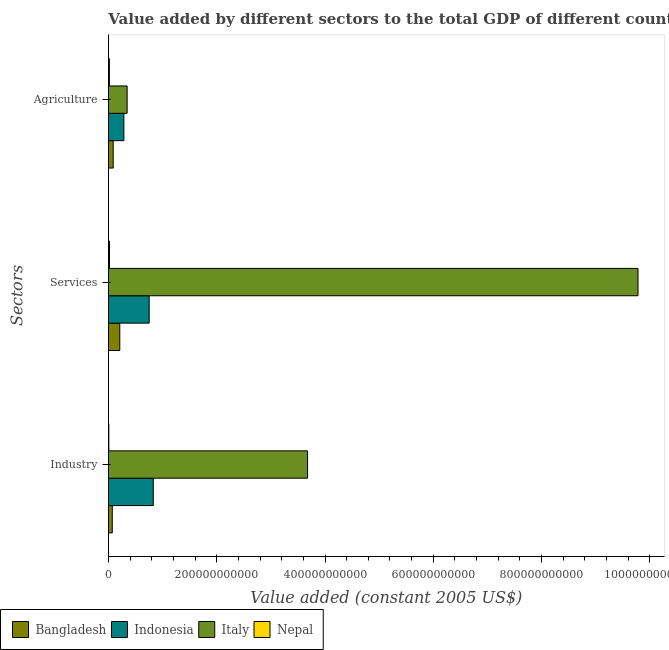How many different coloured bars are there?
Keep it short and to the point. 4. How many groups of bars are there?
Ensure brevity in your answer.  3. Are the number of bars per tick equal to the number of legend labels?
Ensure brevity in your answer.  Yes. How many bars are there on the 1st tick from the top?
Provide a succinct answer. 4. What is the label of the 1st group of bars from the top?
Provide a short and direct response. Agriculture. What is the value added by agricultural sector in Nepal?
Provide a succinct answer. 1.80e+09. Across all countries, what is the maximum value added by agricultural sector?
Give a very brief answer. 3.46e+1. Across all countries, what is the minimum value added by industrial sector?
Offer a terse response. 7.76e+08. In which country was the value added by services minimum?
Offer a terse response. Nepal. What is the total value added by industrial sector in the graph?
Your answer should be compact. 4.59e+11. What is the difference between the value added by industrial sector in Italy and that in Nepal?
Provide a succinct answer. 3.67e+11. What is the difference between the value added by industrial sector in Indonesia and the value added by agricultural sector in Bangladesh?
Offer a terse response. 7.40e+1. What is the average value added by industrial sector per country?
Your answer should be compact. 1.15e+11. What is the difference between the value added by industrial sector and value added by agricultural sector in Nepal?
Offer a terse response. -1.02e+09. In how many countries, is the value added by services greater than 480000000000 US$?
Keep it short and to the point. 1. What is the ratio of the value added by agricultural sector in Bangladesh to that in Italy?
Offer a very short reply. 0.25. Is the difference between the value added by services in Indonesia and Italy greater than the difference between the value added by agricultural sector in Indonesia and Italy?
Give a very brief answer. No. What is the difference between the highest and the second highest value added by services?
Give a very brief answer. 9.03e+11. What is the difference between the highest and the lowest value added by industrial sector?
Your answer should be compact. 3.67e+11. Is the sum of the value added by industrial sector in Indonesia and Bangladesh greater than the maximum value added by services across all countries?
Make the answer very short. No. Is it the case that in every country, the sum of the value added by industrial sector and value added by services is greater than the value added by agricultural sector?
Make the answer very short. Yes. How many countries are there in the graph?
Provide a short and direct response. 4. What is the difference between two consecutive major ticks on the X-axis?
Your answer should be very brief. 2.00e+11. Does the graph contain any zero values?
Provide a succinct answer. No. Where does the legend appear in the graph?
Your response must be concise. Bottom left. How many legend labels are there?
Your answer should be compact. 4. What is the title of the graph?
Offer a terse response. Value added by different sectors to the total GDP of different countries. What is the label or title of the X-axis?
Ensure brevity in your answer.  Value added (constant 2005 US$). What is the label or title of the Y-axis?
Your answer should be compact. Sectors. What is the Value added (constant 2005 US$) of Bangladesh in Industry?
Your response must be concise. 7.11e+09. What is the Value added (constant 2005 US$) in Indonesia in Industry?
Your answer should be compact. 8.29e+1. What is the Value added (constant 2005 US$) of Italy in Industry?
Your answer should be very brief. 3.68e+11. What is the Value added (constant 2005 US$) of Nepal in Industry?
Your answer should be very brief. 7.76e+08. What is the Value added (constant 2005 US$) in Bangladesh in Services?
Offer a very short reply. 2.10e+1. What is the Value added (constant 2005 US$) in Indonesia in Services?
Offer a very short reply. 7.53e+1. What is the Value added (constant 2005 US$) of Italy in Services?
Keep it short and to the point. 9.78e+11. What is the Value added (constant 2005 US$) of Nepal in Services?
Give a very brief answer. 2.01e+09. What is the Value added (constant 2005 US$) of Bangladesh in Agriculture?
Your response must be concise. 8.81e+09. What is the Value added (constant 2005 US$) of Indonesia in Agriculture?
Provide a succinct answer. 2.85e+1. What is the Value added (constant 2005 US$) in Italy in Agriculture?
Keep it short and to the point. 3.46e+1. What is the Value added (constant 2005 US$) of Nepal in Agriculture?
Offer a terse response. 1.80e+09. Across all Sectors, what is the maximum Value added (constant 2005 US$) in Bangladesh?
Provide a succinct answer. 2.10e+1. Across all Sectors, what is the maximum Value added (constant 2005 US$) of Indonesia?
Your answer should be very brief. 8.29e+1. Across all Sectors, what is the maximum Value added (constant 2005 US$) in Italy?
Your answer should be compact. 9.78e+11. Across all Sectors, what is the maximum Value added (constant 2005 US$) of Nepal?
Provide a short and direct response. 2.01e+09. Across all Sectors, what is the minimum Value added (constant 2005 US$) of Bangladesh?
Keep it short and to the point. 7.11e+09. Across all Sectors, what is the minimum Value added (constant 2005 US$) of Indonesia?
Your response must be concise. 2.85e+1. Across all Sectors, what is the minimum Value added (constant 2005 US$) in Italy?
Provide a succinct answer. 3.46e+1. Across all Sectors, what is the minimum Value added (constant 2005 US$) of Nepal?
Offer a terse response. 7.76e+08. What is the total Value added (constant 2005 US$) of Bangladesh in the graph?
Provide a succinct answer. 3.69e+1. What is the total Value added (constant 2005 US$) of Indonesia in the graph?
Your answer should be compact. 1.87e+11. What is the total Value added (constant 2005 US$) of Italy in the graph?
Offer a terse response. 1.38e+12. What is the total Value added (constant 2005 US$) in Nepal in the graph?
Offer a very short reply. 4.59e+09. What is the difference between the Value added (constant 2005 US$) in Bangladesh in Industry and that in Services?
Ensure brevity in your answer.  -1.39e+1. What is the difference between the Value added (constant 2005 US$) in Indonesia in Industry and that in Services?
Offer a very short reply. 7.56e+09. What is the difference between the Value added (constant 2005 US$) of Italy in Industry and that in Services?
Your answer should be compact. -6.10e+11. What is the difference between the Value added (constant 2005 US$) of Nepal in Industry and that in Services?
Provide a short and direct response. -1.24e+09. What is the difference between the Value added (constant 2005 US$) of Bangladesh in Industry and that in Agriculture?
Provide a short and direct response. -1.70e+09. What is the difference between the Value added (constant 2005 US$) of Indonesia in Industry and that in Agriculture?
Keep it short and to the point. 5.43e+1. What is the difference between the Value added (constant 2005 US$) of Italy in Industry and that in Agriculture?
Make the answer very short. 3.33e+11. What is the difference between the Value added (constant 2005 US$) in Nepal in Industry and that in Agriculture?
Provide a succinct answer. -1.02e+09. What is the difference between the Value added (constant 2005 US$) in Bangladesh in Services and that in Agriculture?
Give a very brief answer. 1.22e+1. What is the difference between the Value added (constant 2005 US$) in Indonesia in Services and that in Agriculture?
Make the answer very short. 4.67e+1. What is the difference between the Value added (constant 2005 US$) in Italy in Services and that in Agriculture?
Give a very brief answer. 9.44e+11. What is the difference between the Value added (constant 2005 US$) in Nepal in Services and that in Agriculture?
Your answer should be compact. 2.19e+08. What is the difference between the Value added (constant 2005 US$) in Bangladesh in Industry and the Value added (constant 2005 US$) in Indonesia in Services?
Keep it short and to the point. -6.82e+1. What is the difference between the Value added (constant 2005 US$) in Bangladesh in Industry and the Value added (constant 2005 US$) in Italy in Services?
Make the answer very short. -9.71e+11. What is the difference between the Value added (constant 2005 US$) of Bangladesh in Industry and the Value added (constant 2005 US$) of Nepal in Services?
Keep it short and to the point. 5.09e+09. What is the difference between the Value added (constant 2005 US$) of Indonesia in Industry and the Value added (constant 2005 US$) of Italy in Services?
Make the answer very short. -8.95e+11. What is the difference between the Value added (constant 2005 US$) of Indonesia in Industry and the Value added (constant 2005 US$) of Nepal in Services?
Give a very brief answer. 8.08e+1. What is the difference between the Value added (constant 2005 US$) in Italy in Industry and the Value added (constant 2005 US$) in Nepal in Services?
Your answer should be very brief. 3.66e+11. What is the difference between the Value added (constant 2005 US$) of Bangladesh in Industry and the Value added (constant 2005 US$) of Indonesia in Agriculture?
Provide a short and direct response. -2.14e+1. What is the difference between the Value added (constant 2005 US$) in Bangladesh in Industry and the Value added (constant 2005 US$) in Italy in Agriculture?
Offer a terse response. -2.75e+1. What is the difference between the Value added (constant 2005 US$) of Bangladesh in Industry and the Value added (constant 2005 US$) of Nepal in Agriculture?
Your answer should be very brief. 5.31e+09. What is the difference between the Value added (constant 2005 US$) of Indonesia in Industry and the Value added (constant 2005 US$) of Italy in Agriculture?
Provide a short and direct response. 4.83e+1. What is the difference between the Value added (constant 2005 US$) of Indonesia in Industry and the Value added (constant 2005 US$) of Nepal in Agriculture?
Offer a very short reply. 8.11e+1. What is the difference between the Value added (constant 2005 US$) in Italy in Industry and the Value added (constant 2005 US$) in Nepal in Agriculture?
Ensure brevity in your answer.  3.66e+11. What is the difference between the Value added (constant 2005 US$) in Bangladesh in Services and the Value added (constant 2005 US$) in Indonesia in Agriculture?
Your answer should be compact. -7.58e+09. What is the difference between the Value added (constant 2005 US$) of Bangladesh in Services and the Value added (constant 2005 US$) of Italy in Agriculture?
Offer a very short reply. -1.36e+1. What is the difference between the Value added (constant 2005 US$) of Bangladesh in Services and the Value added (constant 2005 US$) of Nepal in Agriculture?
Provide a short and direct response. 1.92e+1. What is the difference between the Value added (constant 2005 US$) in Indonesia in Services and the Value added (constant 2005 US$) in Italy in Agriculture?
Your answer should be compact. 4.07e+1. What is the difference between the Value added (constant 2005 US$) in Indonesia in Services and the Value added (constant 2005 US$) in Nepal in Agriculture?
Provide a short and direct response. 7.35e+1. What is the difference between the Value added (constant 2005 US$) in Italy in Services and the Value added (constant 2005 US$) in Nepal in Agriculture?
Ensure brevity in your answer.  9.76e+11. What is the average Value added (constant 2005 US$) of Bangladesh per Sectors?
Give a very brief answer. 1.23e+1. What is the average Value added (constant 2005 US$) of Indonesia per Sectors?
Provide a succinct answer. 6.22e+1. What is the average Value added (constant 2005 US$) in Italy per Sectors?
Make the answer very short. 4.60e+11. What is the average Value added (constant 2005 US$) in Nepal per Sectors?
Your answer should be compact. 1.53e+09. What is the difference between the Value added (constant 2005 US$) of Bangladesh and Value added (constant 2005 US$) of Indonesia in Industry?
Make the answer very short. -7.57e+1. What is the difference between the Value added (constant 2005 US$) in Bangladesh and Value added (constant 2005 US$) in Italy in Industry?
Your answer should be compact. -3.61e+11. What is the difference between the Value added (constant 2005 US$) in Bangladesh and Value added (constant 2005 US$) in Nepal in Industry?
Provide a succinct answer. 6.33e+09. What is the difference between the Value added (constant 2005 US$) of Indonesia and Value added (constant 2005 US$) of Italy in Industry?
Provide a short and direct response. -2.85e+11. What is the difference between the Value added (constant 2005 US$) in Indonesia and Value added (constant 2005 US$) in Nepal in Industry?
Provide a short and direct response. 8.21e+1. What is the difference between the Value added (constant 2005 US$) in Italy and Value added (constant 2005 US$) in Nepal in Industry?
Your answer should be very brief. 3.67e+11. What is the difference between the Value added (constant 2005 US$) of Bangladesh and Value added (constant 2005 US$) of Indonesia in Services?
Offer a terse response. -5.43e+1. What is the difference between the Value added (constant 2005 US$) of Bangladesh and Value added (constant 2005 US$) of Italy in Services?
Provide a short and direct response. -9.57e+11. What is the difference between the Value added (constant 2005 US$) in Bangladesh and Value added (constant 2005 US$) in Nepal in Services?
Make the answer very short. 1.89e+1. What is the difference between the Value added (constant 2005 US$) of Indonesia and Value added (constant 2005 US$) of Italy in Services?
Offer a very short reply. -9.03e+11. What is the difference between the Value added (constant 2005 US$) of Indonesia and Value added (constant 2005 US$) of Nepal in Services?
Your answer should be very brief. 7.33e+1. What is the difference between the Value added (constant 2005 US$) in Italy and Value added (constant 2005 US$) in Nepal in Services?
Give a very brief answer. 9.76e+11. What is the difference between the Value added (constant 2005 US$) of Bangladesh and Value added (constant 2005 US$) of Indonesia in Agriculture?
Your answer should be very brief. -1.97e+1. What is the difference between the Value added (constant 2005 US$) in Bangladesh and Value added (constant 2005 US$) in Italy in Agriculture?
Ensure brevity in your answer.  -2.58e+1. What is the difference between the Value added (constant 2005 US$) of Bangladesh and Value added (constant 2005 US$) of Nepal in Agriculture?
Your answer should be compact. 7.01e+09. What is the difference between the Value added (constant 2005 US$) in Indonesia and Value added (constant 2005 US$) in Italy in Agriculture?
Offer a very short reply. -6.03e+09. What is the difference between the Value added (constant 2005 US$) of Indonesia and Value added (constant 2005 US$) of Nepal in Agriculture?
Give a very brief answer. 2.67e+1. What is the difference between the Value added (constant 2005 US$) in Italy and Value added (constant 2005 US$) in Nepal in Agriculture?
Offer a terse response. 3.28e+1. What is the ratio of the Value added (constant 2005 US$) in Bangladesh in Industry to that in Services?
Ensure brevity in your answer.  0.34. What is the ratio of the Value added (constant 2005 US$) of Indonesia in Industry to that in Services?
Offer a very short reply. 1.1. What is the ratio of the Value added (constant 2005 US$) in Italy in Industry to that in Services?
Provide a succinct answer. 0.38. What is the ratio of the Value added (constant 2005 US$) in Nepal in Industry to that in Services?
Keep it short and to the point. 0.39. What is the ratio of the Value added (constant 2005 US$) of Bangladesh in Industry to that in Agriculture?
Provide a short and direct response. 0.81. What is the ratio of the Value added (constant 2005 US$) of Indonesia in Industry to that in Agriculture?
Your response must be concise. 2.9. What is the ratio of the Value added (constant 2005 US$) of Italy in Industry to that in Agriculture?
Make the answer very short. 10.64. What is the ratio of the Value added (constant 2005 US$) of Nepal in Industry to that in Agriculture?
Offer a very short reply. 0.43. What is the ratio of the Value added (constant 2005 US$) of Bangladesh in Services to that in Agriculture?
Ensure brevity in your answer.  2.38. What is the ratio of the Value added (constant 2005 US$) of Indonesia in Services to that in Agriculture?
Your answer should be very brief. 2.64. What is the ratio of the Value added (constant 2005 US$) of Italy in Services to that in Agriculture?
Offer a terse response. 28.29. What is the ratio of the Value added (constant 2005 US$) of Nepal in Services to that in Agriculture?
Ensure brevity in your answer.  1.12. What is the difference between the highest and the second highest Value added (constant 2005 US$) of Bangladesh?
Ensure brevity in your answer.  1.22e+1. What is the difference between the highest and the second highest Value added (constant 2005 US$) in Indonesia?
Provide a succinct answer. 7.56e+09. What is the difference between the highest and the second highest Value added (constant 2005 US$) in Italy?
Provide a short and direct response. 6.10e+11. What is the difference between the highest and the second highest Value added (constant 2005 US$) of Nepal?
Your answer should be very brief. 2.19e+08. What is the difference between the highest and the lowest Value added (constant 2005 US$) of Bangladesh?
Give a very brief answer. 1.39e+1. What is the difference between the highest and the lowest Value added (constant 2005 US$) in Indonesia?
Your answer should be compact. 5.43e+1. What is the difference between the highest and the lowest Value added (constant 2005 US$) in Italy?
Offer a terse response. 9.44e+11. What is the difference between the highest and the lowest Value added (constant 2005 US$) in Nepal?
Offer a terse response. 1.24e+09. 